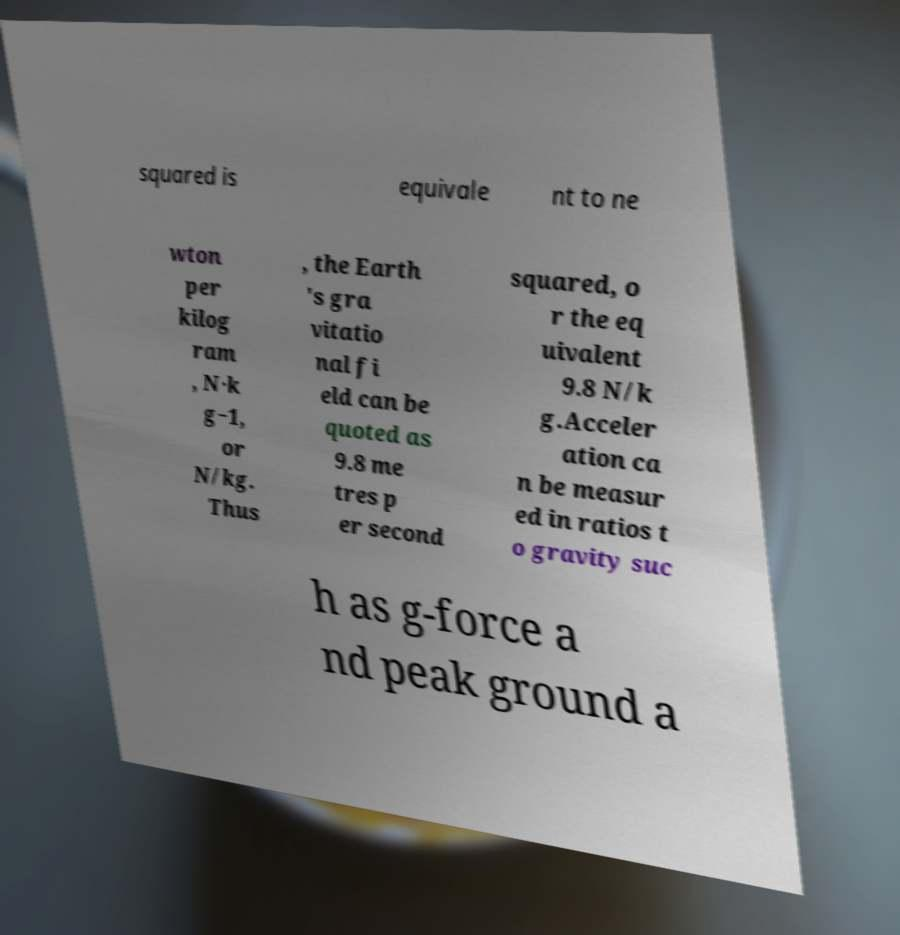What messages or text are displayed in this image? I need them in a readable, typed format. squared is equivale nt to ne wton per kilog ram , N·k g−1, or N/kg. Thus , the Earth 's gra vitatio nal fi eld can be quoted as 9.8 me tres p er second squared, o r the eq uivalent 9.8 N/k g.Acceler ation ca n be measur ed in ratios t o gravity suc h as g-force a nd peak ground a 